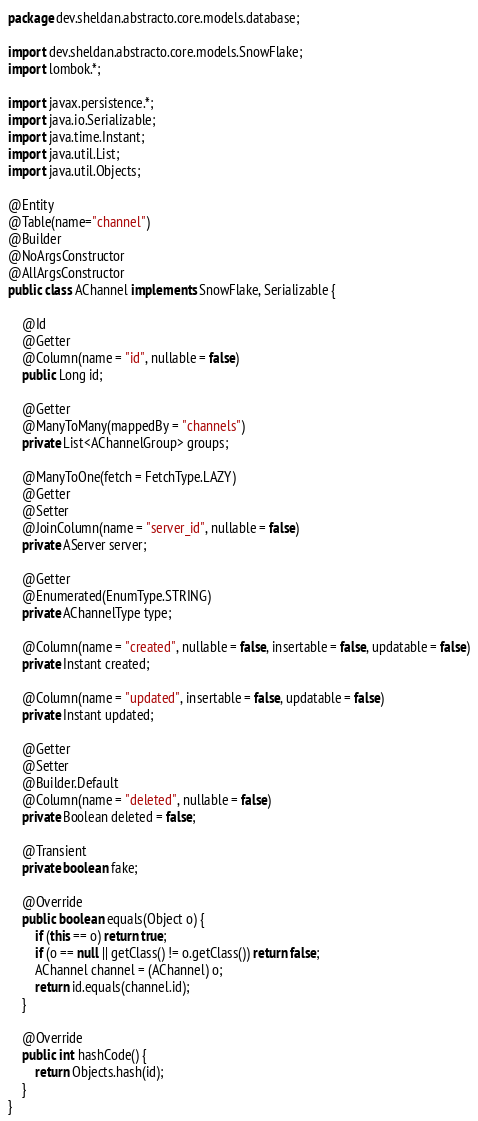Convert code to text. <code><loc_0><loc_0><loc_500><loc_500><_Java_>package dev.sheldan.abstracto.core.models.database;

import dev.sheldan.abstracto.core.models.SnowFlake;
import lombok.*;

import javax.persistence.*;
import java.io.Serializable;
import java.time.Instant;
import java.util.List;
import java.util.Objects;

@Entity
@Table(name="channel")
@Builder
@NoArgsConstructor
@AllArgsConstructor
public class AChannel implements SnowFlake, Serializable {

    @Id
    @Getter
    @Column(name = "id", nullable = false)
    public Long id;

    @Getter
    @ManyToMany(mappedBy = "channels")
    private List<AChannelGroup> groups;

    @ManyToOne(fetch = FetchType.LAZY)
    @Getter
    @Setter
    @JoinColumn(name = "server_id", nullable = false)
    private AServer server;

    @Getter
    @Enumerated(EnumType.STRING)
    private AChannelType type;

    @Column(name = "created", nullable = false, insertable = false, updatable = false)
    private Instant created;

    @Column(name = "updated", insertable = false, updatable = false)
    private Instant updated;

    @Getter
    @Setter
    @Builder.Default
    @Column(name = "deleted", nullable = false)
    private Boolean deleted = false;

    @Transient
    private boolean fake;

    @Override
    public boolean equals(Object o) {
        if (this == o) return true;
        if (o == null || getClass() != o.getClass()) return false;
        AChannel channel = (AChannel) o;
        return id.equals(channel.id);
    }

    @Override
    public int hashCode() {
        return Objects.hash(id);
    }
}
</code> 